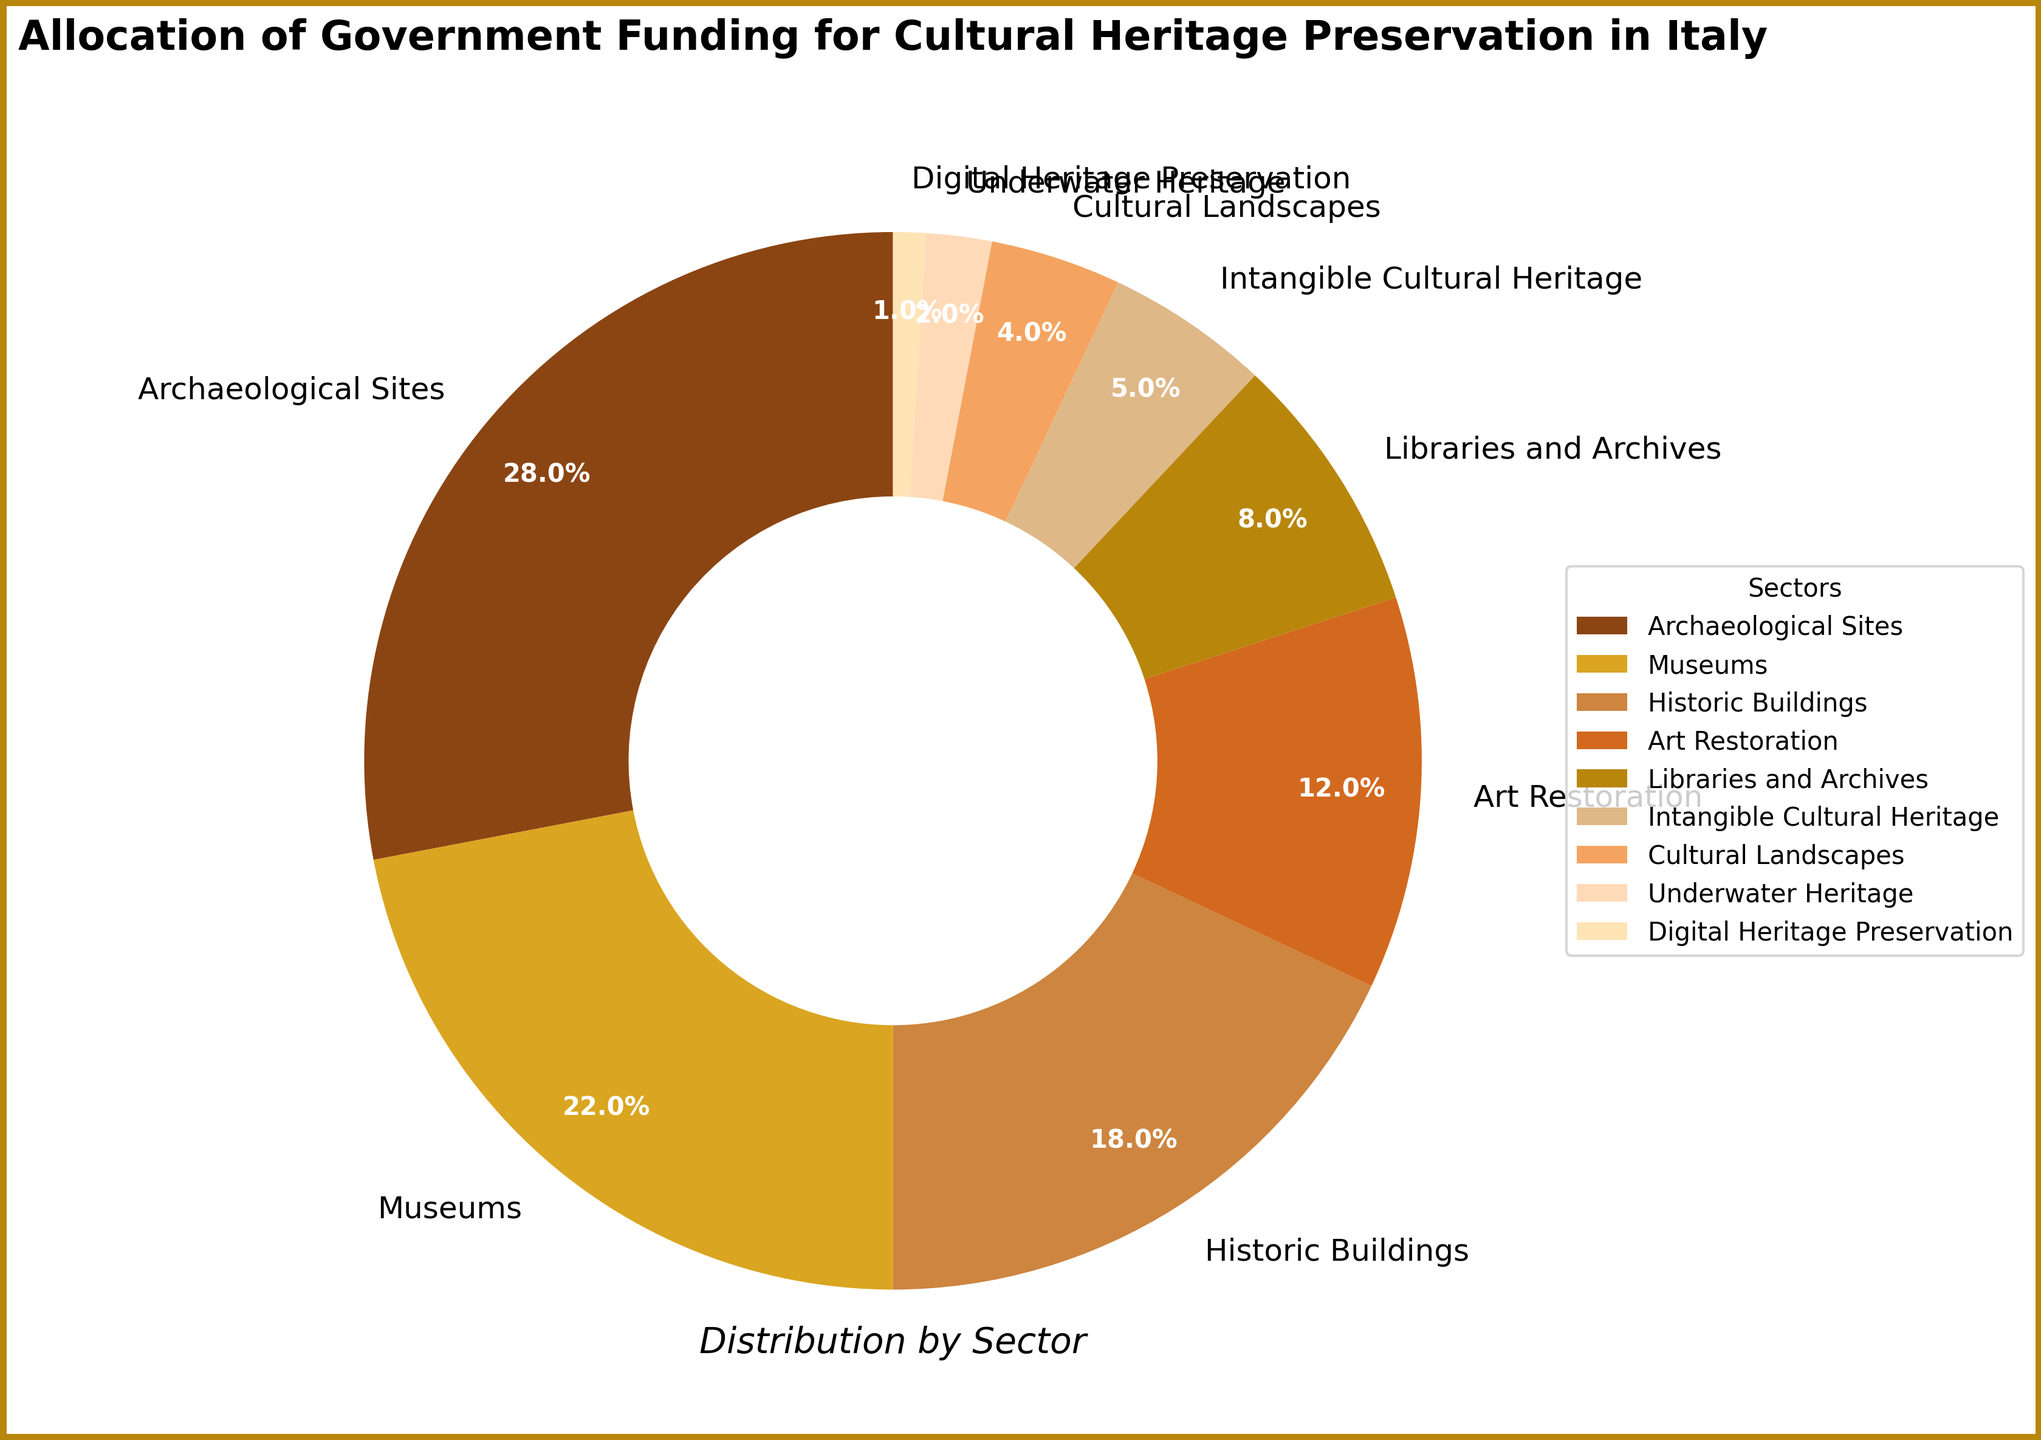What sector receives the highest percentage of government funding? From the pie chart, the largest wedge is labeled 'Archaeological Sites', which corresponds to 28%.
Answer: Archaeological Sites How much more funding percentage do Museums receive compared to Digital Heritage Preservation? Museums receive 22% and Digital Heritage Preservation receives 1%. The difference is calculated as 22% - 1%.
Answer: 21% Which sectors receive less than 10% of the total funding? From the chart, sectors with wedges labeled 'Libraries and Archives', 'Intangible Cultural Heritage', 'Cultural Landscapes', 'Underwater Heritage', and 'Digital Heritage Preservation' fall below the 10% threshold, receiving 8%, 5%, 4%, 2%, and 1% respectively.
Answer: Libraries and Archives, Intangible Cultural Heritage, Cultural Landscapes, Underwater Heritage, Digital Heritage Preservation What is the combined funding percentage for Historic Buildings and Art Restoration? Adding the percentages for Historic Buildings (18%) and Art Restoration (12%), we get 18% + 12%.
Answer: 30% Which sector has the smallest wedge, and what is its funding percentage? The smallest wedge on the pie chart is labeled 'Digital Heritage Preservation', which receives 1% of the funding.
Answer: Digital Heritage Preservation, 1% What percentage of funding is allocated to sectors other than Archaeological Sites and Museums? Subtract the percentages of Archaeological Sites (28%) and Museums (22%) from the total 100%, i.e., 100% - 28% - 22%.
Answer: 50% Are there more sectors receiving funding percentages above or below 10%? We count the sectors with funding above 10% (Archaeological Sites, Museums, Historic Buildings, Art Restoration) which are 4, and those below 10% (Libraries and Archives, Intangible Cultural Heritage, Cultural Landscapes, Underwater Heritage, Digital Heritage Preservation) which are 5.
Answer: Below 10% How does the percentage of funding for Intangible Cultural Heritage compare to Underwater Heritage? Intangible Cultural Heritage receives 5% while Underwater Heritage receives 2%. To compare, 5% is greater than 2%.
Answer: Intangible Cultural Heritage receives more Which sector’s funding is colored brown and what is its percentage? According to the pie chart's custom color palette, the wedge colored brown corresponds to 'Archaeological Sites', receiving 28%.
Answer: Archaeological Sites, 28% What is the total percentage of funding allocated to sectors categorized as 'Digital' and 'Underwater' heritage? Adding the funding for 'Digital Heritage Preservation' (1%) and 'Underwater Heritage' (2%), we get 1% + 2%.
Answer: 3% 